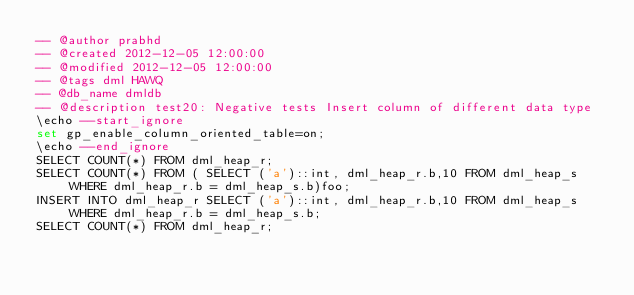Convert code to text. <code><loc_0><loc_0><loc_500><loc_500><_SQL_>-- @author prabhd 
-- @created 2012-12-05 12:00:00 
-- @modified 2012-12-05 12:00:00 
-- @tags dml HAWQ 
-- @db_name dmldb
-- @description test20: Negative tests Insert column of different data type
\echo --start_ignore
set gp_enable_column_oriented_table=on;
\echo --end_ignore
SELECT COUNT(*) FROM dml_heap_r;
SELECT COUNT(*) FROM ( SELECT ('a')::int, dml_heap_r.b,10 FROM dml_heap_s WHERE dml_heap_r.b = dml_heap_s.b)foo;
INSERT INTO dml_heap_r SELECT ('a')::int, dml_heap_r.b,10 FROM dml_heap_s WHERE dml_heap_r.b = dml_heap_s.b;
SELECT COUNT(*) FROM dml_heap_r;
</code> 